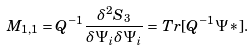Convert formula to latex. <formula><loc_0><loc_0><loc_500><loc_500>M _ { 1 , 1 } = Q ^ { - 1 } \frac { \delta ^ { 2 } S _ { 3 } } { \delta \Psi _ { i } \delta \Psi _ { i } } = T r [ Q ^ { - 1 } \Psi * ] .</formula> 